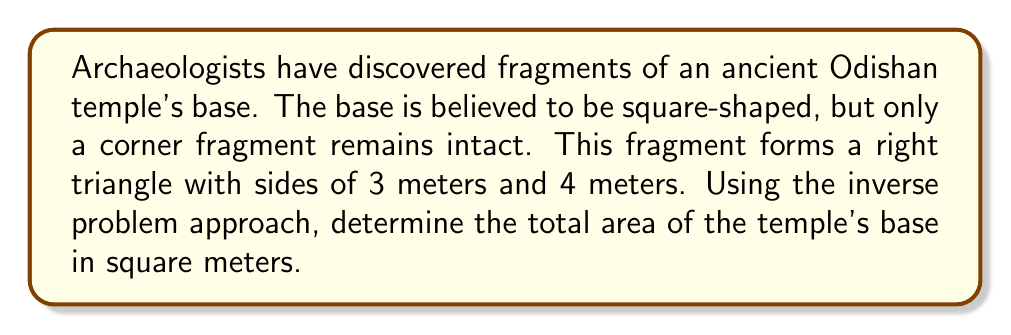Can you answer this question? Let's approach this step-by-step:

1) We are given a right triangle fragment with sides of 3 meters and 4 meters. This forms part of the square base of the temple.

2) In a right triangle, we can use the Pythagorean theorem to find the length of the hypotenuse:

   $$a^2 + b^2 = c^2$$
   $$3^2 + 4^2 = c^2$$
   $$9 + 16 = c^2$$
   $$25 = c^2$$
   $$c = 5$$

3) This hypotenuse of 5 meters represents the side length of the square base.

4) To find the area of a square, we use the formula:

   $$A = s^2$$

   where $A$ is the area and $s$ is the side length.

5) Substituting our side length:

   $$A = 5^2 = 25$$

Therefore, the total area of the temple's base is 25 square meters.

This is an inverse problem because we're using a small piece of information (the fragment) to reconstruct a larger whole (the entire temple base). We've inferred the complete structure from partial data.
Answer: 25 sq meters 